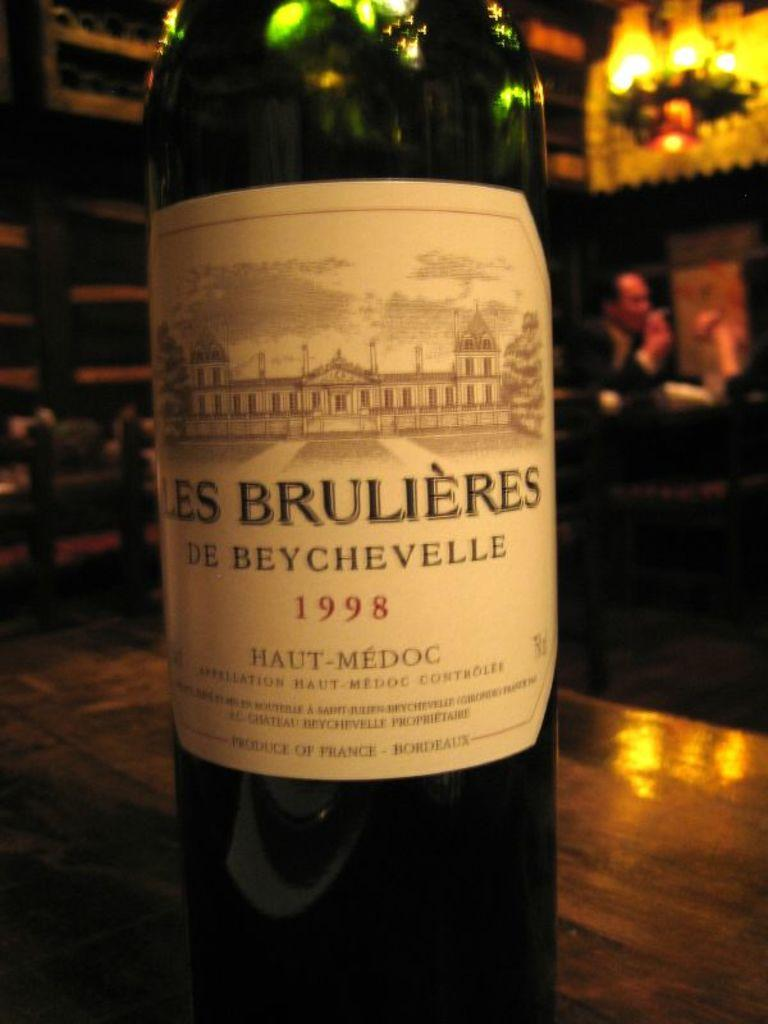<image>
Share a concise interpretation of the image provided. A bottle of wine from 1998 sits on a tabletop. 